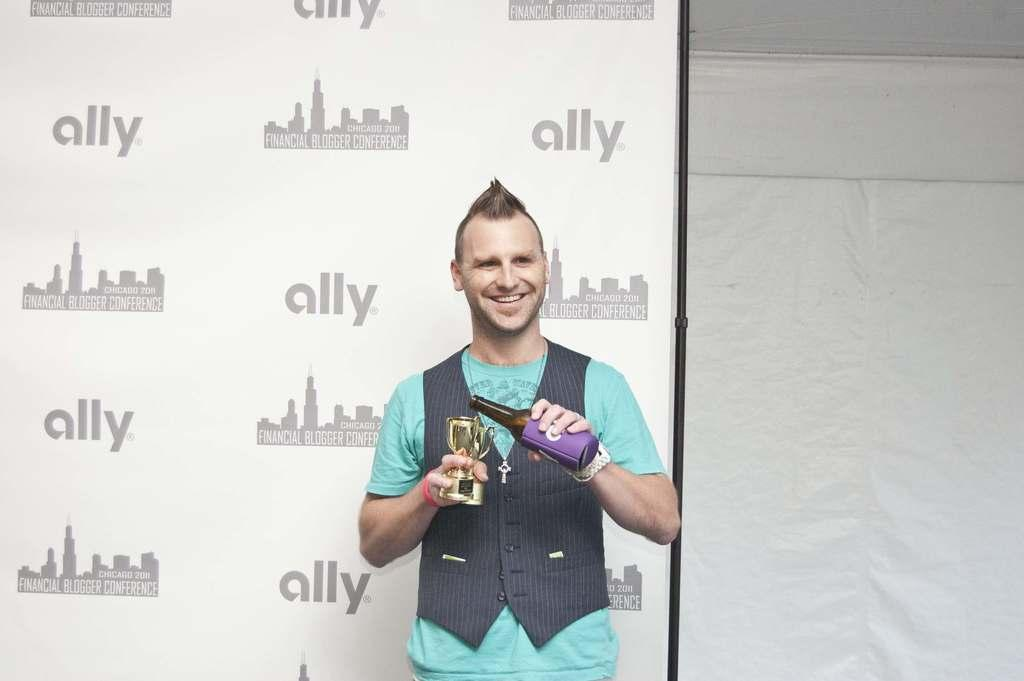Who is the main subject in the image? There is a boy in the image. Where is the boy positioned in the image? The boy is standing in the center of the image. What is the boy holding in his hands? The boy is holding a bottle and two glasses. What can be seen behind the boy in the image? There is a poster behind the boy. Who is the owner of the credit card in the image? There is no credit card present in the image. Can you tell me which elbow the boy is using to hold the bottle? The image does not provide enough detail to determine which elbow the boy is using to hold the bottle. 